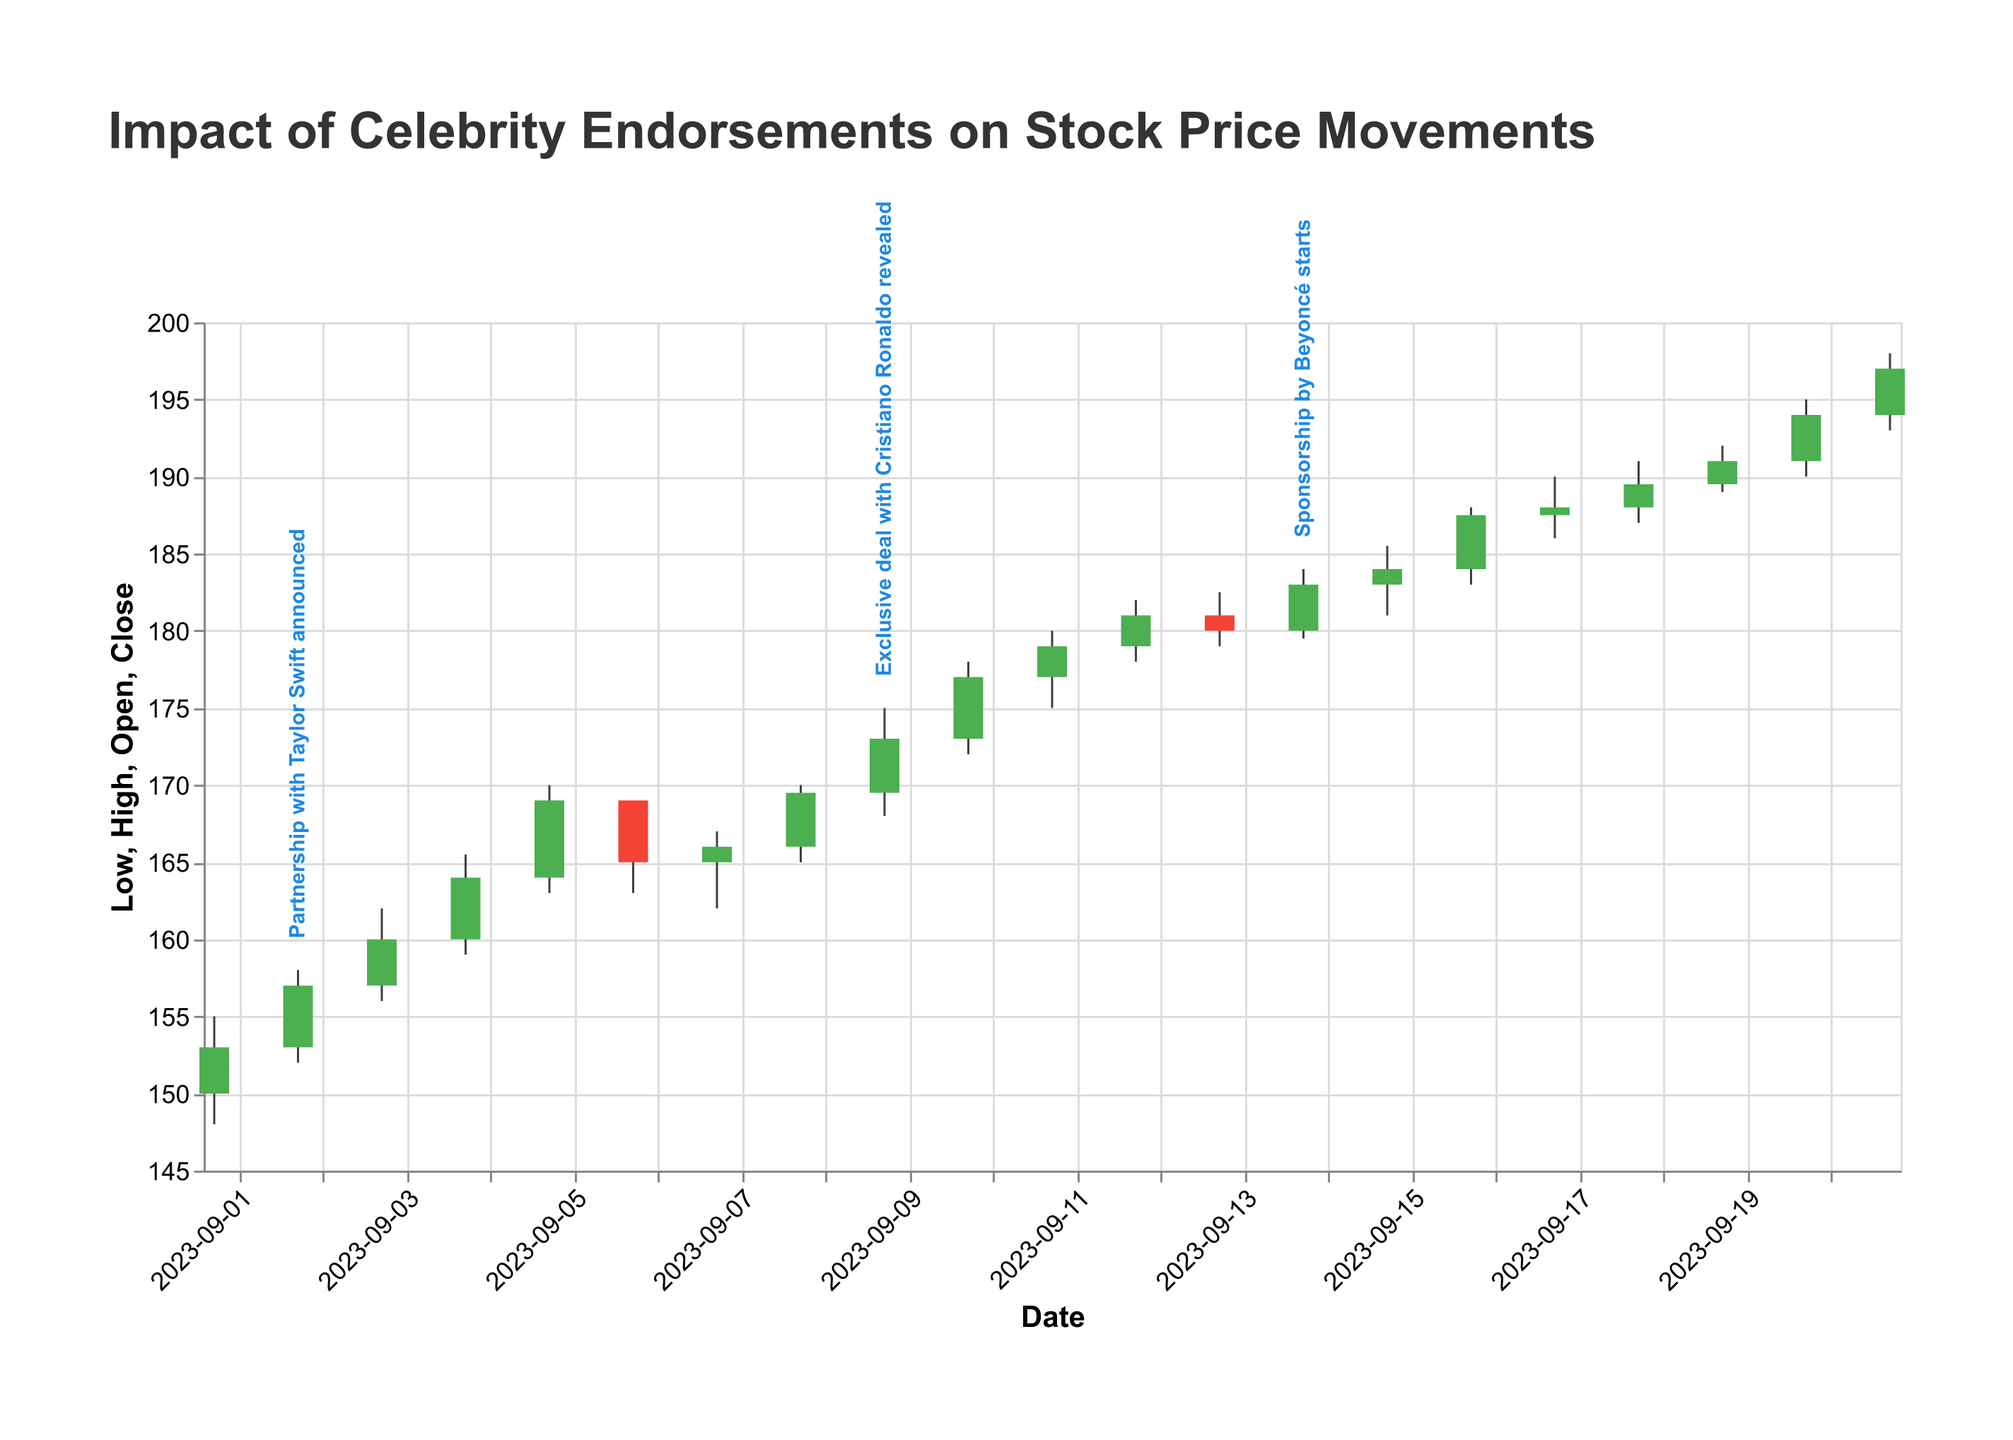Which date had the highest trading volume and what was the volume? The figure indicates volume for each date. By examining the height of the volume bars, the highest volume occurred on 2023-09-21 with a trading volume of 2,100,000.
Answer: 2023-09-21, 2,100,000 Did the stock price generally increase or decrease after the announcement of the partnership with Taylor Swift on 2023-09-02? The stock price on 2023-09-02 was $157 at close. By looking at the subsequent prices, the stock price increased over the following days. Specifically, on 2023-09-05 it reached $169.
Answer: Increase Compare the closing price on the day Beyoncé's sponsorship started with the closing price on the following day. Which was higher and by how much? On 2023-09-14 (when Beyoncé's sponsorship started), the closing price was $183. On the following day, 2023-09-15, the closing price was $184. The price on the following day was higher by $1.
Answer: 2023-09-15, $1 How did the stock price respond to the exclusive deal with Cristiano Ronaldo revealed on 2023-09-09? On 2023-09-09, the stock closed at $173. On subsequent days, the price continued to climb, closing at $177 on 2023-09-10, $179 on 2023-09-11, and $181 on 2023-09-12. This indicates a positive response.
Answer: Positive increase What was the highest stock price (High) reached during the observed period and on which date? The highest stock price (High) during the observed period was $198, which occurred on 2023-09-21.
Answer: $198, 2023-09-21 Compare the overall trend of stock prices before and after September 8, 2023. Did the stock prices exhibit a general increase or decrease after this date? Before September 8, the closing prices were gradually increasing but experienced some volatility. After September 8, the prices continued to increase and reached higher peaks more frequently. Generally, there was a sustained increase after this date.
Answer: General increase Identify any dates when the closing price was higher than both the opening and closing prices from the previous day. Name at least two such dates. On 2023-09-05, the closing price was $169, which was higher than the previous day's closing ($164) and opening ($160) prices. Similarly, on 2023-09-10, the closing price was $177, higher than the previous day's closing ($173) and opening ($169.5).
Answer: 2023-09-05, 2023-09-10 